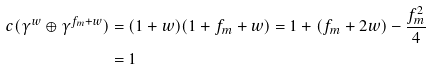Convert formula to latex. <formula><loc_0><loc_0><loc_500><loc_500>c ( \gamma ^ { w } \oplus \gamma ^ { f _ { m } + w } ) & = ( 1 + w ) ( 1 + f _ { m } + w ) = 1 + ( f _ { m } + 2 w ) - \frac { f _ { m } ^ { 2 } } { 4 } \\ & = 1</formula> 